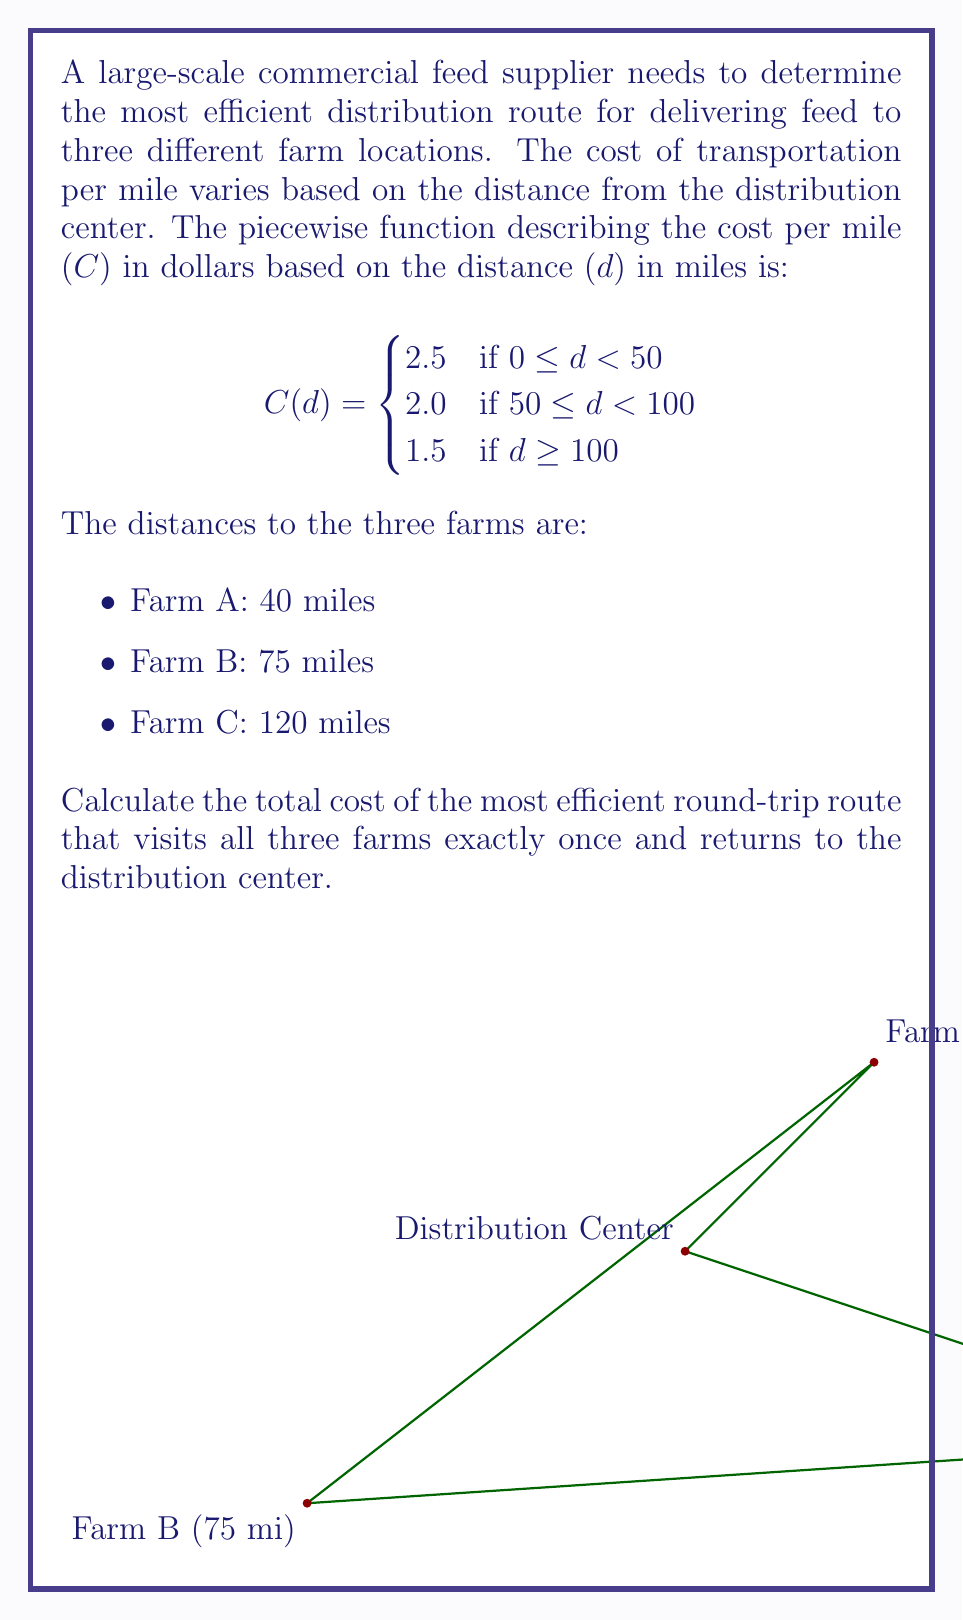Help me with this question. Let's approach this step-by-step:

1) First, we need to calculate the cost for each leg of the journey using the piecewise function.

2) For Farm A (40 miles):
   $C(40) = 2.5$ (since $0 \leq 40 < 50$)
   Cost = $40 \times 2.5 = 100$

3) For Farm B (75 miles):
   $C(75) = 2.0$ (since $50 \leq 75 < 100$)
   Cost = $75 \times 2.0 = 150$

4) For Farm C (120 miles):
   $C(120) = 1.5$ (since $120 \geq 100$)
   Cost = $120 \times 1.5 = 180$

5) Now, we need to determine the most efficient route. The total distance will be the same regardless of the order (275 miles), but the cost will vary based on which segments use which rate.

6) The most efficient route will be the one that uses the lower rates for the longer distances. So, the optimal order is:
   Distribution Center → Farm A → Farm B → Farm C → Distribution Center

7) Let's calculate the cost for this route:
   DC to A: 40 miles at $2.5/mile = $100
   A to B: 75 miles at $2.0/mile = $150
   B to C: 120 miles at $1.5/mile = $180
   C to DC: 120 miles at $1.5/mile = $180

8) Total cost: $100 + $150 + $180 + $180 = $610

Therefore, the total cost of the most efficient round-trip route is $610.
Answer: $610 